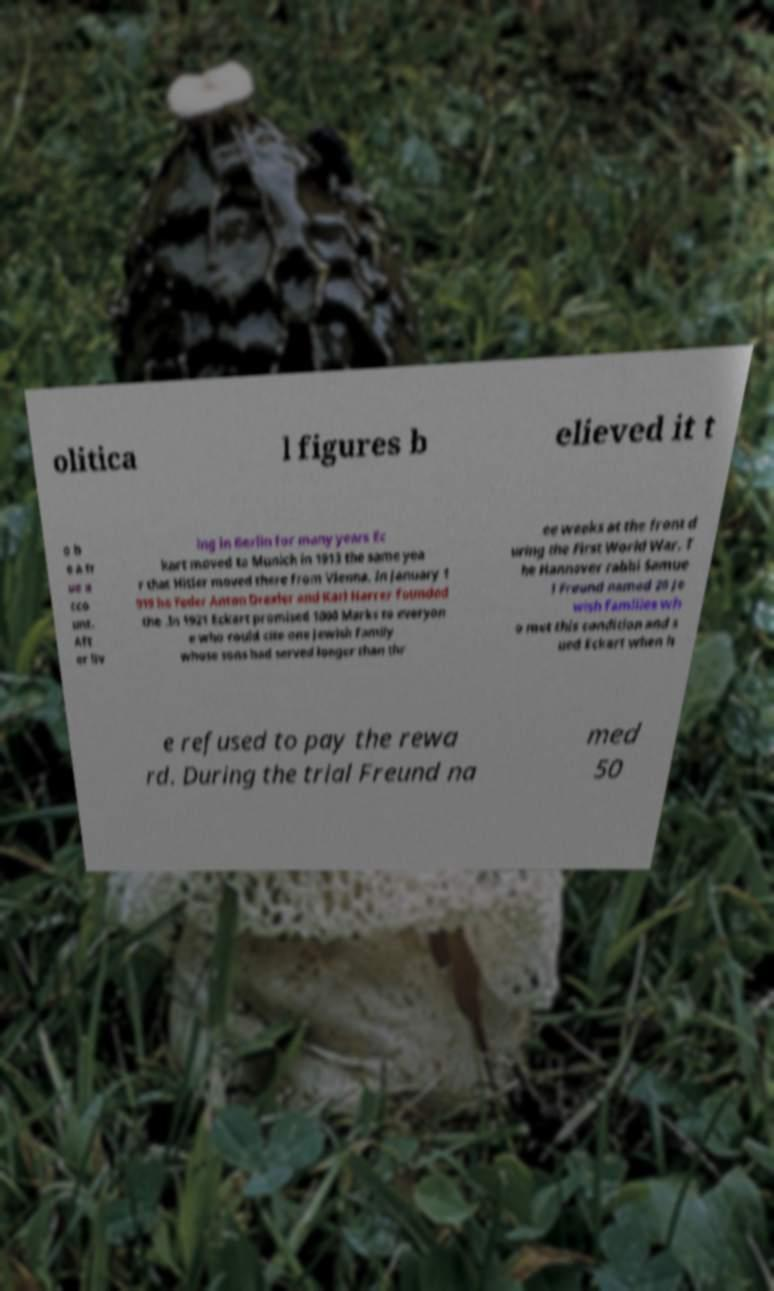What messages or text are displayed in this image? I need them in a readable, typed format. olitica l figures b elieved it t o b e a tr ue a cco unt. Aft er liv ing in Berlin for many years Ec kart moved to Munich in 1913 the same yea r that Hitler moved there from Vienna. In January 1 919 he Feder Anton Drexler and Karl Harrer founded the .In 1921 Eckart promised 1000 Marks to everyon e who could cite one Jewish family whose sons had served longer than thr ee weeks at the front d uring the First World War. T he Hannover rabbi Samue l Freund named 20 Je wish families wh o met this condition and s ued Eckart when h e refused to pay the rewa rd. During the trial Freund na med 50 